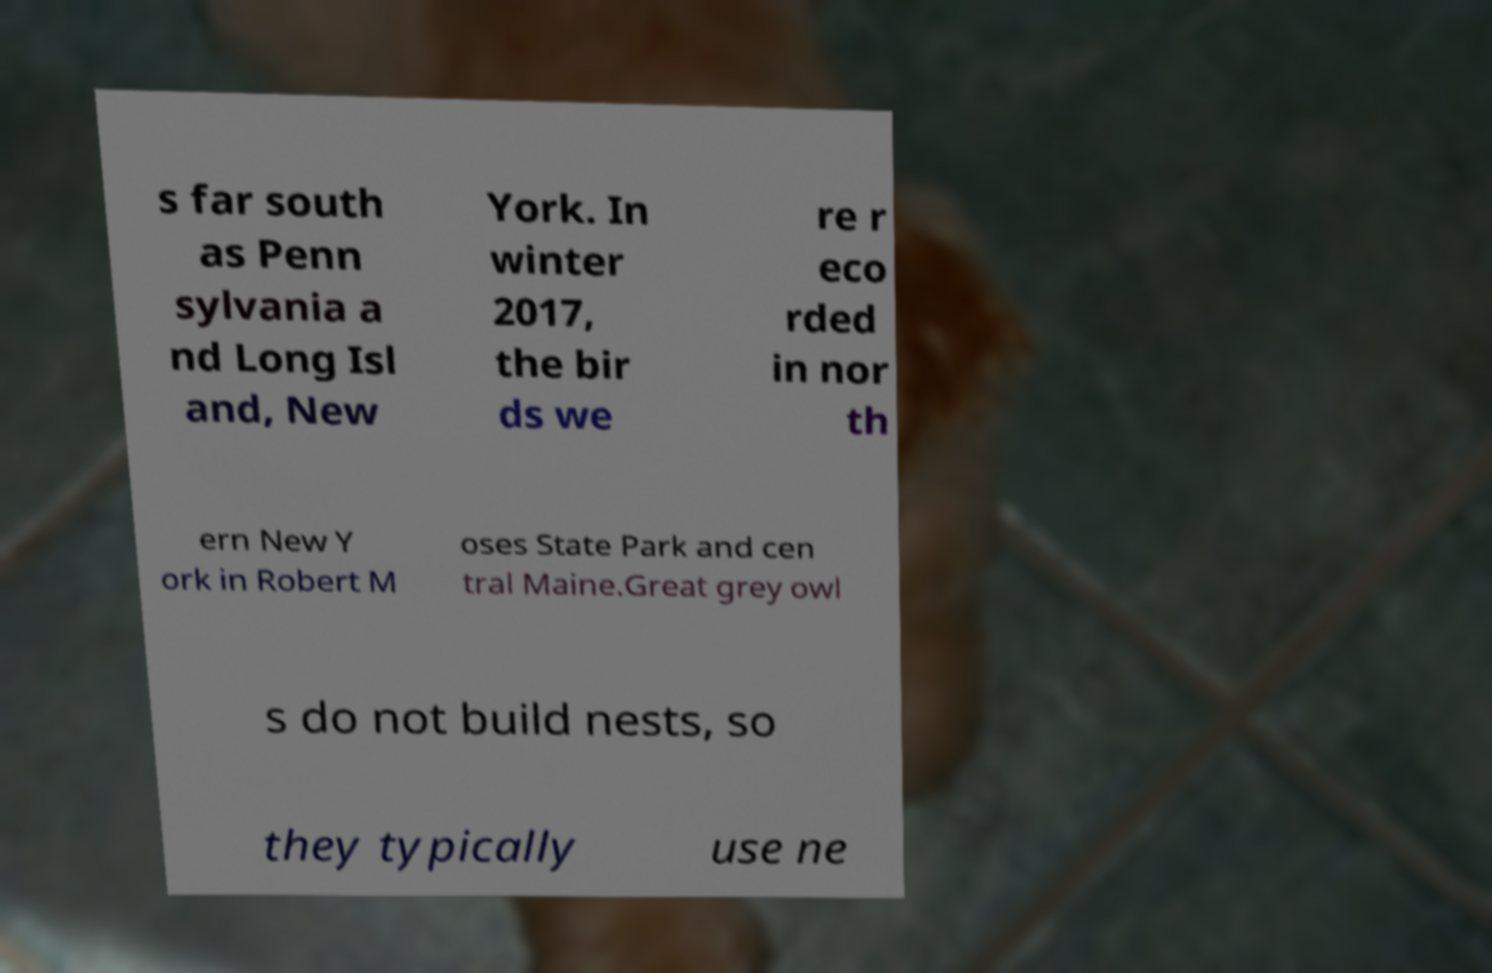For documentation purposes, I need the text within this image transcribed. Could you provide that? s far south as Penn sylvania a nd Long Isl and, New York. In winter 2017, the bir ds we re r eco rded in nor th ern New Y ork in Robert M oses State Park and cen tral Maine.Great grey owl s do not build nests, so they typically use ne 